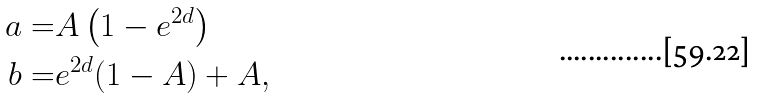<formula> <loc_0><loc_0><loc_500><loc_500>a = & A \left ( 1 - e ^ { 2 d } \right ) \\ b = & e ^ { 2 d } ( 1 - A ) + A ,</formula> 